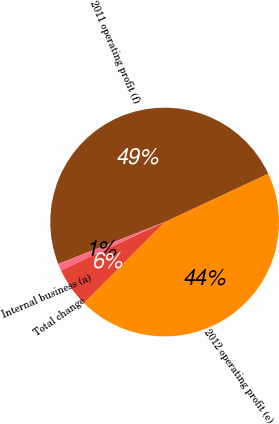<chart> <loc_0><loc_0><loc_500><loc_500><pie_chart><fcel>2012 operating profit (e)<fcel>2011 operating profit (f)<fcel>Internal business (a)<fcel>Total change<nl><fcel>44.43%<fcel>49.02%<fcel>0.98%<fcel>5.57%<nl></chart> 